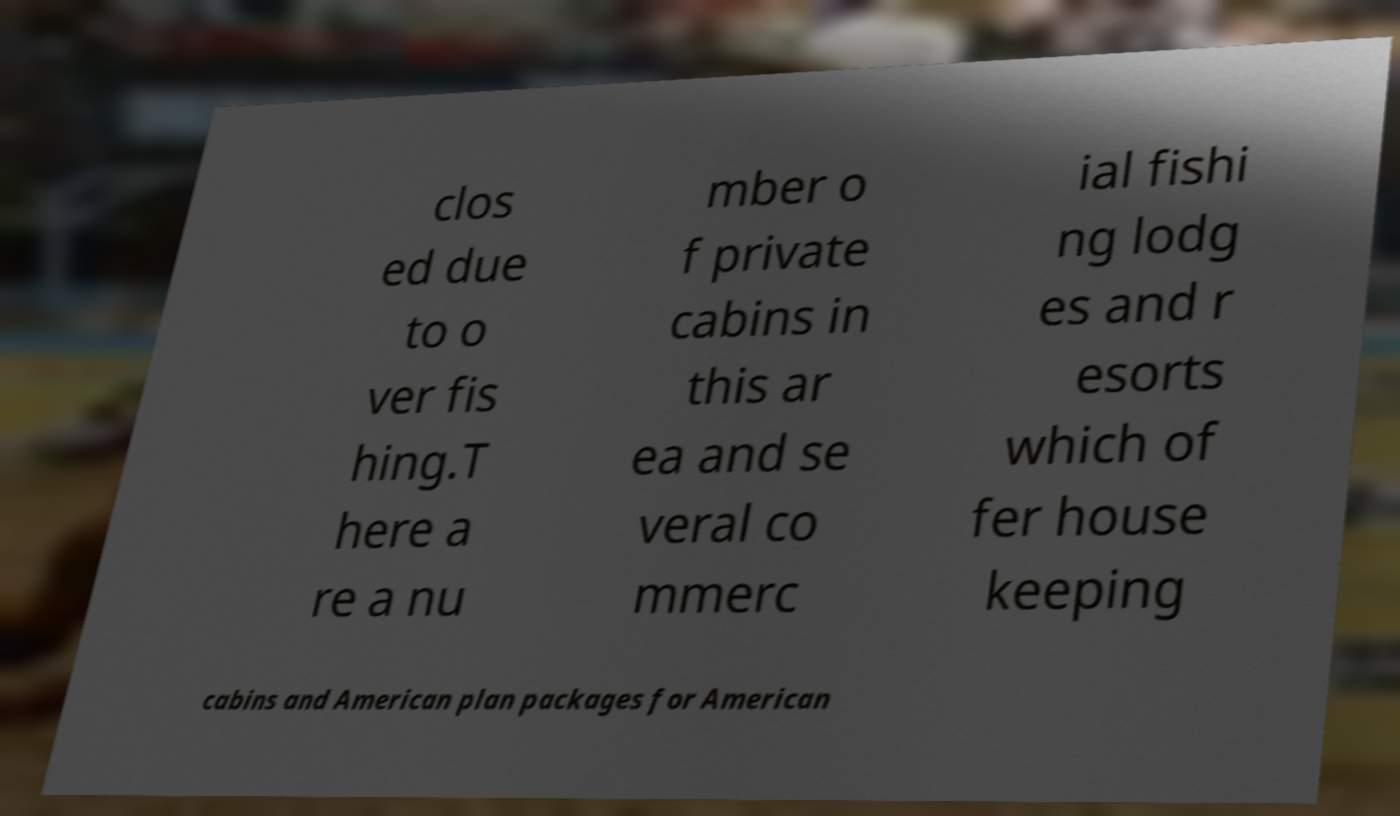For documentation purposes, I need the text within this image transcribed. Could you provide that? clos ed due to o ver fis hing.T here a re a nu mber o f private cabins in this ar ea and se veral co mmerc ial fishi ng lodg es and r esorts which of fer house keeping cabins and American plan packages for American 